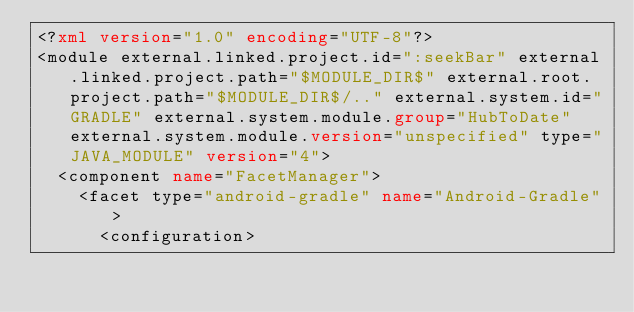Convert code to text. <code><loc_0><loc_0><loc_500><loc_500><_XML_><?xml version="1.0" encoding="UTF-8"?>
<module external.linked.project.id=":seekBar" external.linked.project.path="$MODULE_DIR$" external.root.project.path="$MODULE_DIR$/.." external.system.id="GRADLE" external.system.module.group="HubToDate" external.system.module.version="unspecified" type="JAVA_MODULE" version="4">
  <component name="FacetManager">
    <facet type="android-gradle" name="Android-Gradle">
      <configuration></code> 